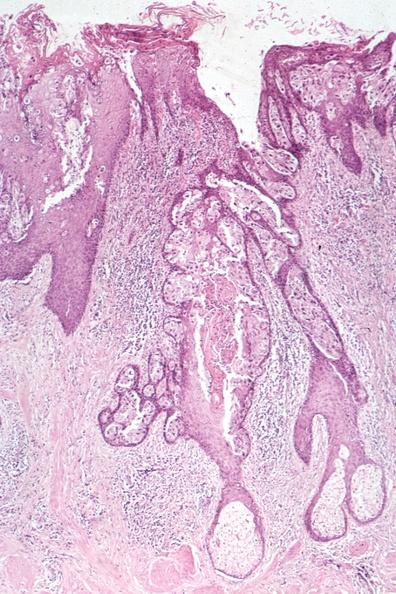where is this area in the body?
Answer the question using a single word or phrase. Breast 